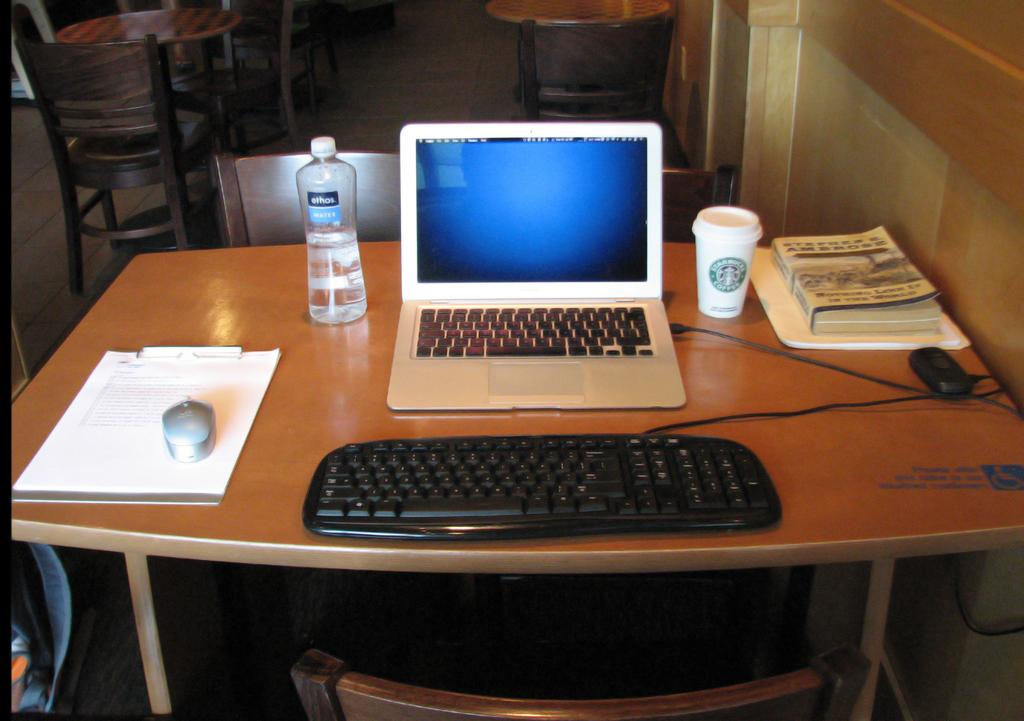What electronic device is visible in the image? There is a laptop in the image. What can be seen next to the laptop? There is a water bottle and a cup in the image. What items related to studying or work are present in the image? There are books, a keyboard, and a mouse in the image. Where are these objects located? The objects are on a table in the image. What type of furniture is visible in the image? There are chairs in the image, both in the foreground and the background. What type of blood is visible on the laptop in the image? There is no blood visible on the laptop or any other objects in the image. 